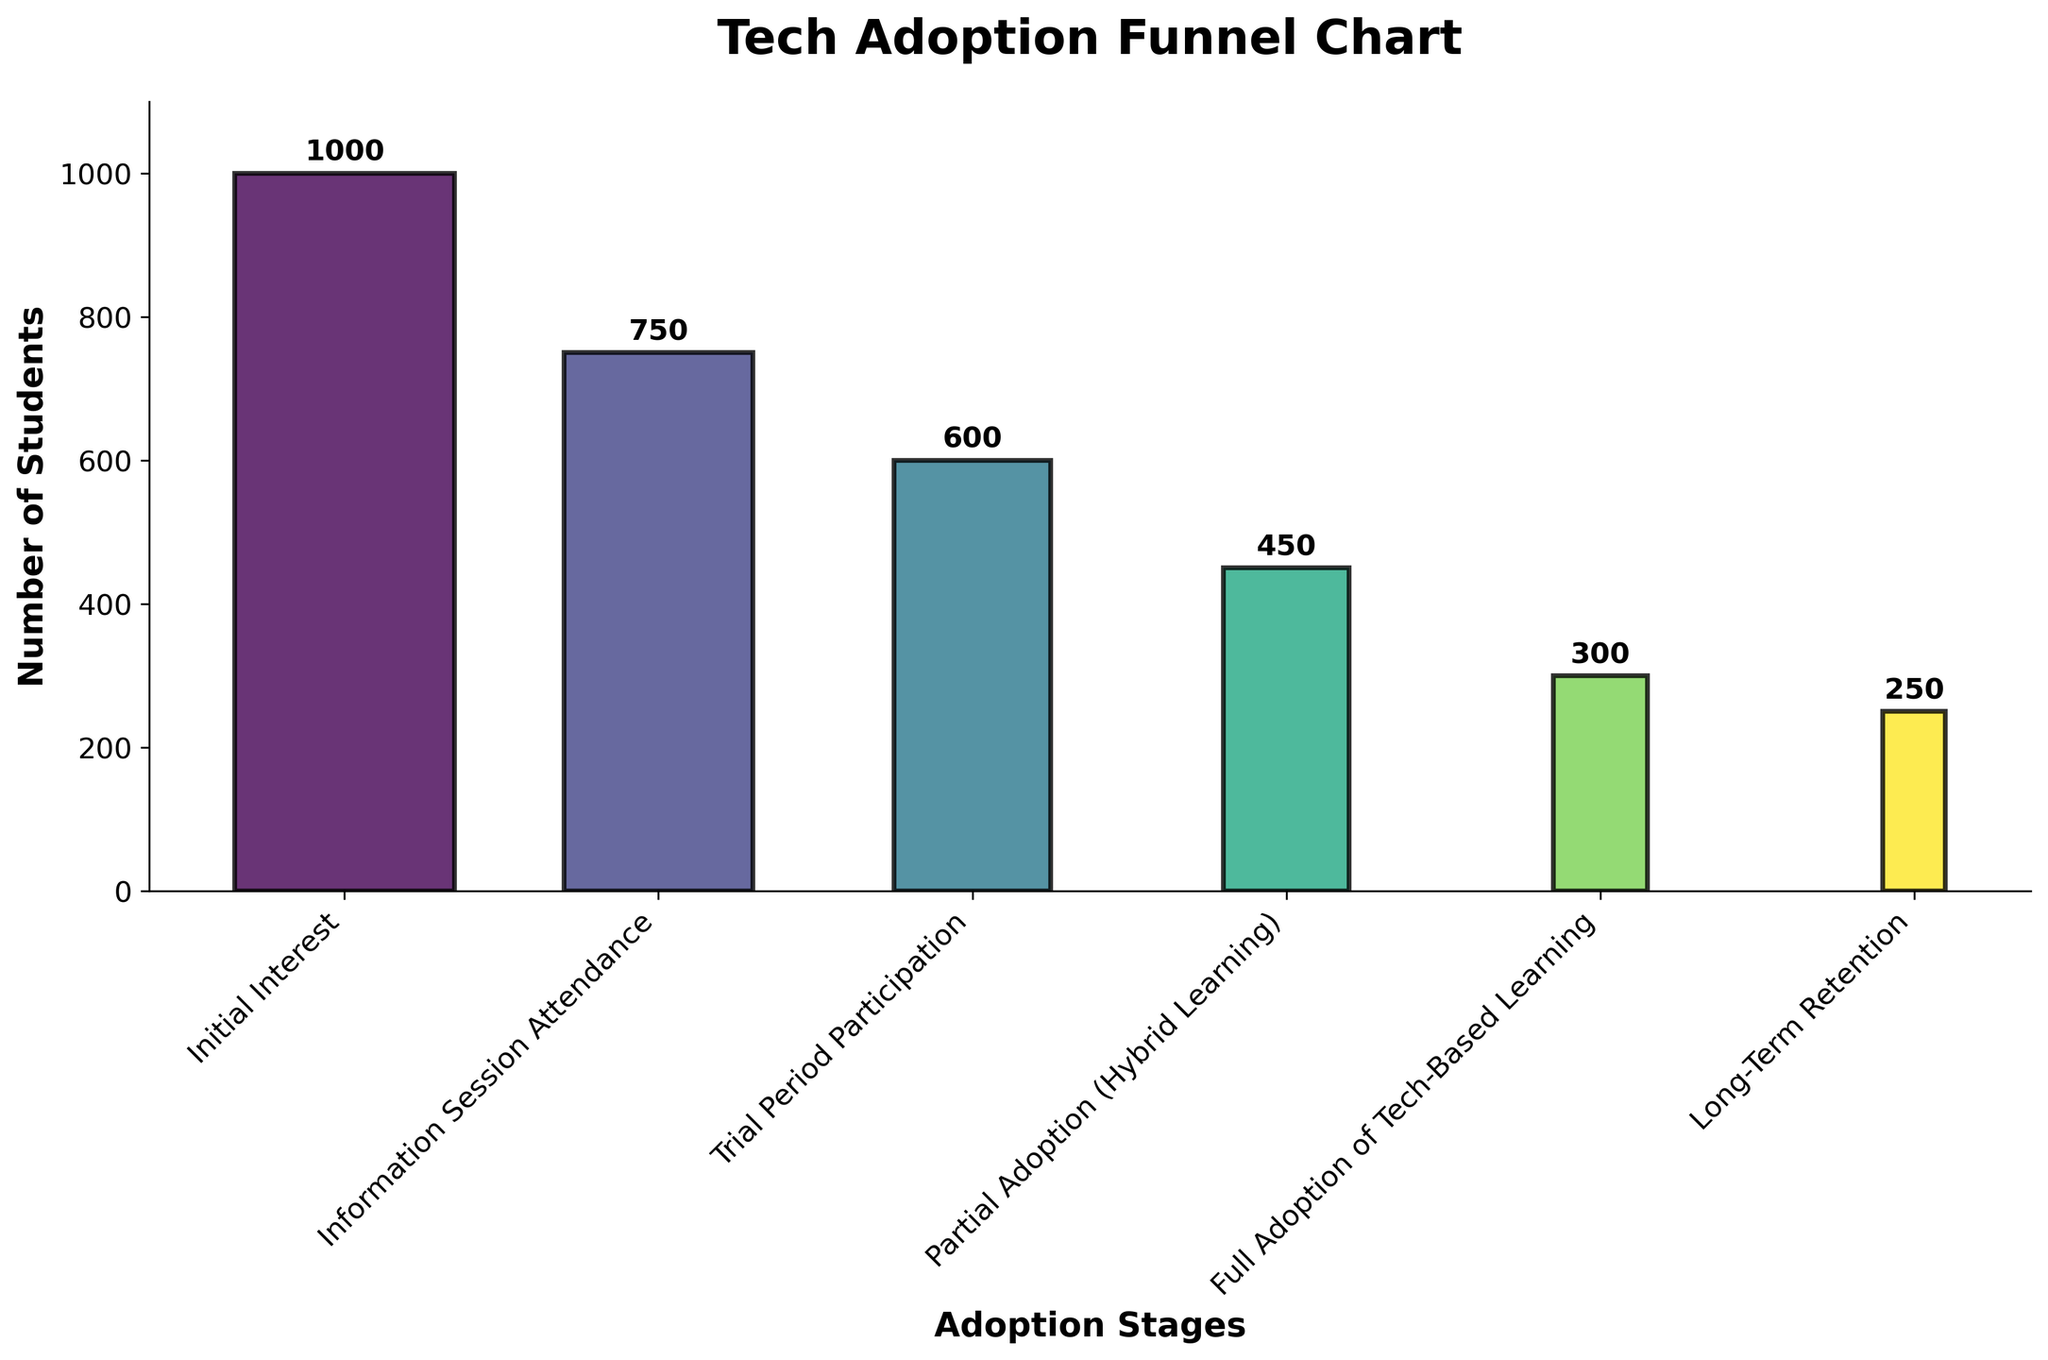What is the title of the chart? The title is displayed at the top of the chart. It is in large, bold, and centered text.
Answer: Tech Adoption Funnel Chart How many stages are there in the funnel chart? Each bar in the funnel chart represents a stage. Count the number of bars to determine the number of stages.
Answer: 6 Which stage has the highest number of students? Compare the heights of all the bars and identify the tallest one, which indicates the highest number of students.
Answer: Initial Interest What is the number of students in the 'Partial Adoption (Hybrid Learning)' stage? Locate the 'Partial Adoption (Hybrid Learning)' label on the x-axis and read the corresponding value indicated by the height of the bar and the annotation above it.
Answer: 450 How many students drop from the 'Information Session Attendance' stage to the 'Trial Period Participation' stage? Subtract the number of students in the 'Trial Period Participation' stage from the 'Information Session Attendance' stage: 750 - 600.
Answer: 150 What is the percentage drop from the 'Initial Interest' stage to the 'Full Adoption of Tech-Based Learning' stage? Calculate the difference in the number of students between these stages then divide by the initial number, followed by multiplying by 100: (1000 - 300) / 1000 * 100.
Answer: 70% Which stage has the lowest number of students? Compare the heights of all the bars and identify the shortest one, which indicates the lowest number of students.
Answer: Long-Term Retention What is the total drop in the number of students from 'Initial Interest' to 'Long-Term Retention'? Subtract the number of students in the 'Long-Term Retention' stage from the 'Initial Interest' stage: 1000 - 250.
Answer: 750 How many students participate through at least the 'Trial Period Participation' stage? Identify the number of students at the 'Trial Period Participation' stage; all these students have passed through the earlier stages.
Answer: 600 